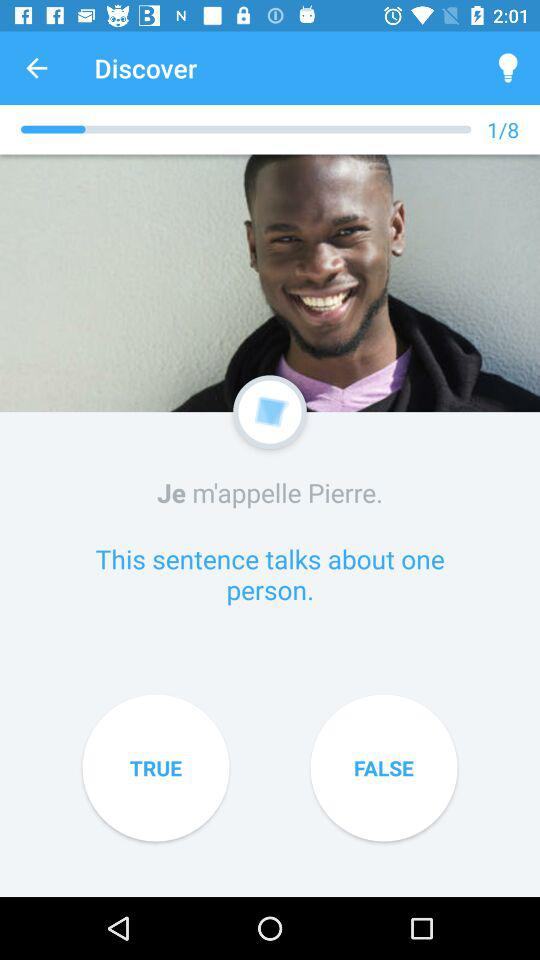How many questions are there? There are 8 questions. 